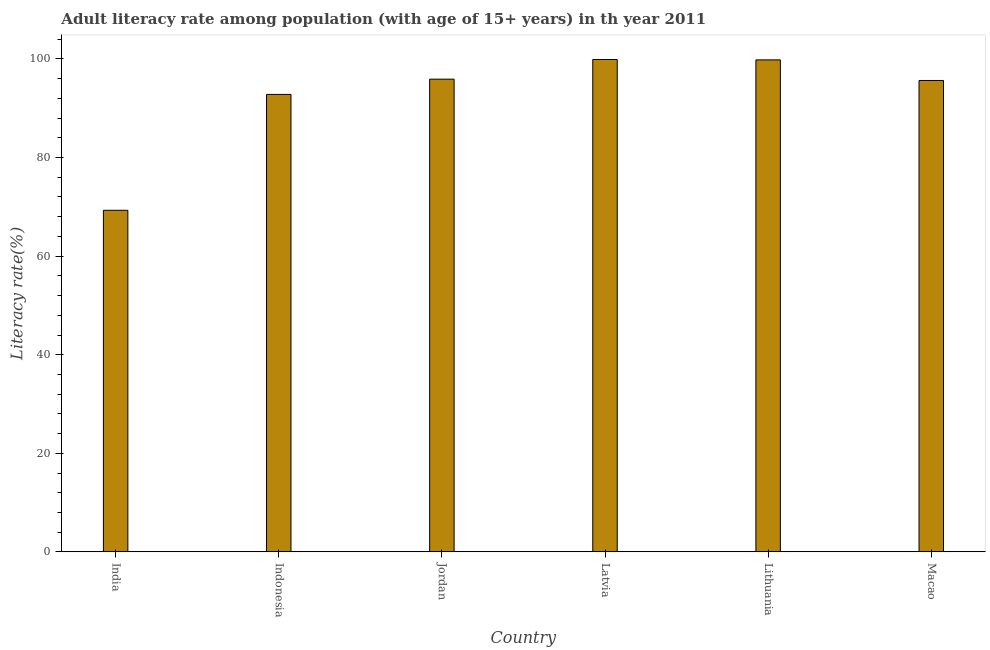Does the graph contain any zero values?
Your response must be concise. No. What is the title of the graph?
Ensure brevity in your answer.  Adult literacy rate among population (with age of 15+ years) in th year 2011. What is the label or title of the Y-axis?
Offer a very short reply. Literacy rate(%). What is the adult literacy rate in Lithuania?
Offer a very short reply. 99.82. Across all countries, what is the maximum adult literacy rate?
Your response must be concise. 99.9. Across all countries, what is the minimum adult literacy rate?
Keep it short and to the point. 69.3. In which country was the adult literacy rate maximum?
Your answer should be compact. Latvia. In which country was the adult literacy rate minimum?
Offer a terse response. India. What is the sum of the adult literacy rate?
Keep it short and to the point. 553.37. What is the difference between the adult literacy rate in India and Indonesia?
Provide a succinct answer. -23.51. What is the average adult literacy rate per country?
Make the answer very short. 92.23. What is the median adult literacy rate?
Ensure brevity in your answer.  95.77. What is the ratio of the adult literacy rate in India to that in Latvia?
Ensure brevity in your answer.  0.69. What is the difference between the highest and the second highest adult literacy rate?
Offer a very short reply. 0.08. What is the difference between the highest and the lowest adult literacy rate?
Ensure brevity in your answer.  30.59. Are all the bars in the graph horizontal?
Provide a short and direct response. No. How many countries are there in the graph?
Provide a short and direct response. 6. Are the values on the major ticks of Y-axis written in scientific E-notation?
Your answer should be very brief. No. What is the Literacy rate(%) of India?
Provide a short and direct response. 69.3. What is the Literacy rate(%) in Indonesia?
Give a very brief answer. 92.81. What is the Literacy rate(%) in Jordan?
Your response must be concise. 95.9. What is the Literacy rate(%) in Latvia?
Ensure brevity in your answer.  99.9. What is the Literacy rate(%) of Lithuania?
Your answer should be very brief. 99.82. What is the Literacy rate(%) in Macao?
Keep it short and to the point. 95.64. What is the difference between the Literacy rate(%) in India and Indonesia?
Your answer should be compact. -23.51. What is the difference between the Literacy rate(%) in India and Jordan?
Provide a short and direct response. -26.6. What is the difference between the Literacy rate(%) in India and Latvia?
Give a very brief answer. -30.59. What is the difference between the Literacy rate(%) in India and Lithuania?
Give a very brief answer. -30.51. What is the difference between the Literacy rate(%) in India and Macao?
Make the answer very short. -26.34. What is the difference between the Literacy rate(%) in Indonesia and Jordan?
Ensure brevity in your answer.  -3.09. What is the difference between the Literacy rate(%) in Indonesia and Latvia?
Make the answer very short. -7.08. What is the difference between the Literacy rate(%) in Indonesia and Lithuania?
Offer a terse response. -7. What is the difference between the Literacy rate(%) in Indonesia and Macao?
Provide a short and direct response. -2.83. What is the difference between the Literacy rate(%) in Jordan and Latvia?
Provide a succinct answer. -3.99. What is the difference between the Literacy rate(%) in Jordan and Lithuania?
Your response must be concise. -3.91. What is the difference between the Literacy rate(%) in Jordan and Macao?
Keep it short and to the point. 0.26. What is the difference between the Literacy rate(%) in Latvia and Lithuania?
Keep it short and to the point. 0.08. What is the difference between the Literacy rate(%) in Latvia and Macao?
Provide a succinct answer. 4.26. What is the difference between the Literacy rate(%) in Lithuania and Macao?
Your answer should be compact. 4.18. What is the ratio of the Literacy rate(%) in India to that in Indonesia?
Provide a succinct answer. 0.75. What is the ratio of the Literacy rate(%) in India to that in Jordan?
Provide a succinct answer. 0.72. What is the ratio of the Literacy rate(%) in India to that in Latvia?
Your response must be concise. 0.69. What is the ratio of the Literacy rate(%) in India to that in Lithuania?
Give a very brief answer. 0.69. What is the ratio of the Literacy rate(%) in India to that in Macao?
Provide a short and direct response. 0.72. What is the ratio of the Literacy rate(%) in Indonesia to that in Latvia?
Provide a short and direct response. 0.93. What is the ratio of the Literacy rate(%) in Indonesia to that in Lithuania?
Offer a very short reply. 0.93. What is the ratio of the Literacy rate(%) in Latvia to that in Macao?
Provide a succinct answer. 1.04. What is the ratio of the Literacy rate(%) in Lithuania to that in Macao?
Make the answer very short. 1.04. 